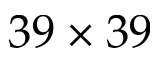Convert formula to latex. <formula><loc_0><loc_0><loc_500><loc_500>3 9 \times 3 9</formula> 